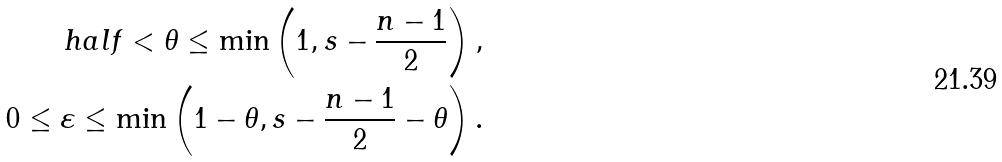<formula> <loc_0><loc_0><loc_500><loc_500>\ h a l f < \theta \leq \min \left ( 1 , s - \frac { n - 1 } { 2 } \right ) , \\ 0 \leq \varepsilon \leq \min \left ( 1 - \theta , s - \frac { n - 1 } { 2 } - \theta \right ) .</formula> 